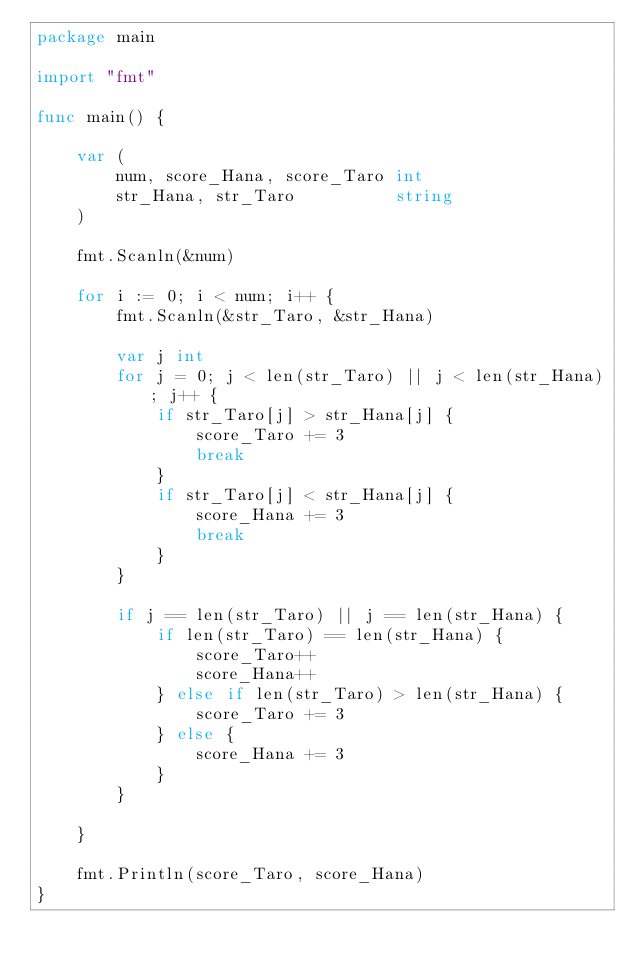<code> <loc_0><loc_0><loc_500><loc_500><_Go_>package main

import "fmt"

func main() {

	var (
		num, score_Hana, score_Taro int
		str_Hana, str_Taro          string
	)

	fmt.Scanln(&num)

	for i := 0; i < num; i++ {
		fmt.Scanln(&str_Taro, &str_Hana)

		var j int
		for j = 0; j < len(str_Taro) || j < len(str_Hana); j++ {
			if str_Taro[j] > str_Hana[j] {
				score_Taro += 3
				break
			}
			if str_Taro[j] < str_Hana[j] {
				score_Hana += 3
				break
			}
		}

		if j == len(str_Taro) || j == len(str_Hana) {
			if len(str_Taro) == len(str_Hana) {
				score_Taro++
				score_Hana++
			} else if len(str_Taro) > len(str_Hana) {
				score_Taro += 3
			} else {
				score_Hana += 3
			}
		}

	}

	fmt.Println(score_Taro, score_Hana)
}

</code> 